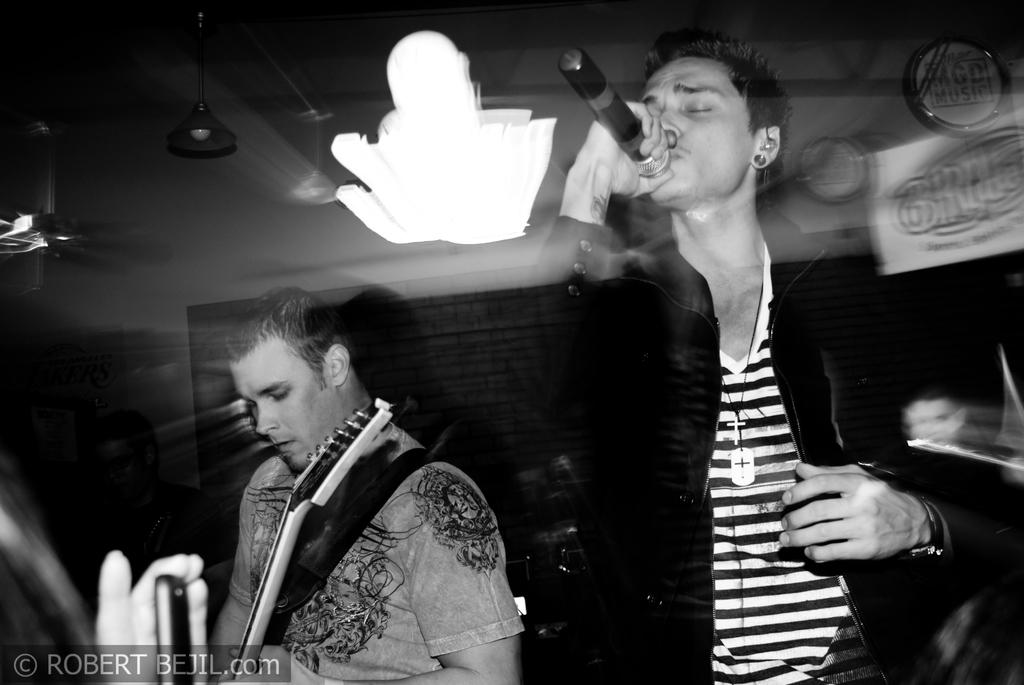How many people are in the image? There are two persons in the image. What is one person doing in the image? One person is playing a guitar. What is the other person doing in the image? The other person is singing. What type of underwear is the person wearing while playing the guitar in the image? There is no information about the person's underwear in the image, and therefore it cannot be determined. 